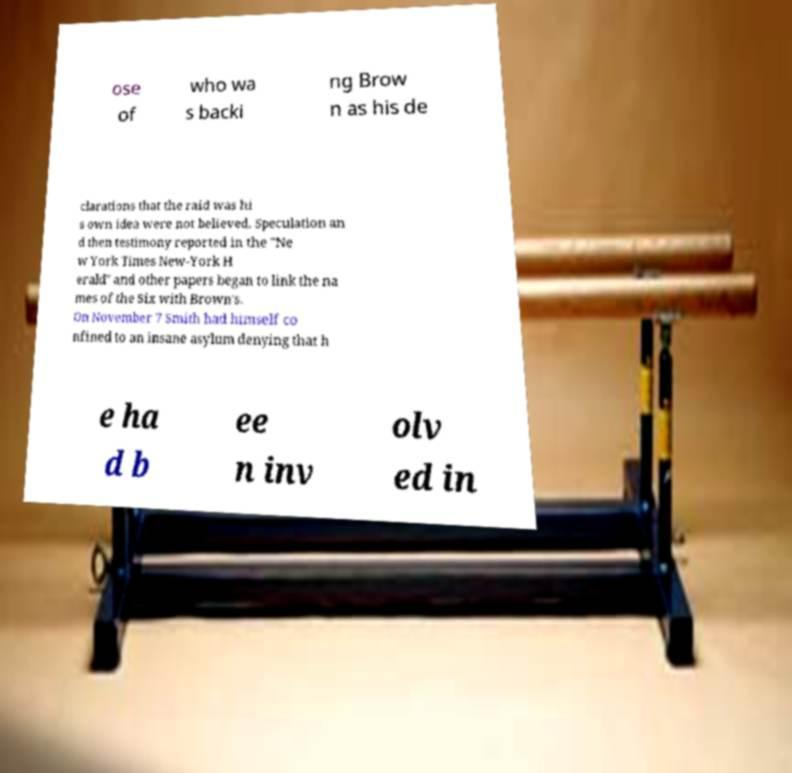There's text embedded in this image that I need extracted. Can you transcribe it verbatim? ose of who wa s backi ng Brow n as his de clarations that the raid was hi s own idea were not believed. Speculation an d then testimony reported in the "Ne w York Times New-York H erald" and other papers began to link the na mes of the Six with Brown's. On November 7 Smith had himself co nfined to an insane asylum denying that h e ha d b ee n inv olv ed in 